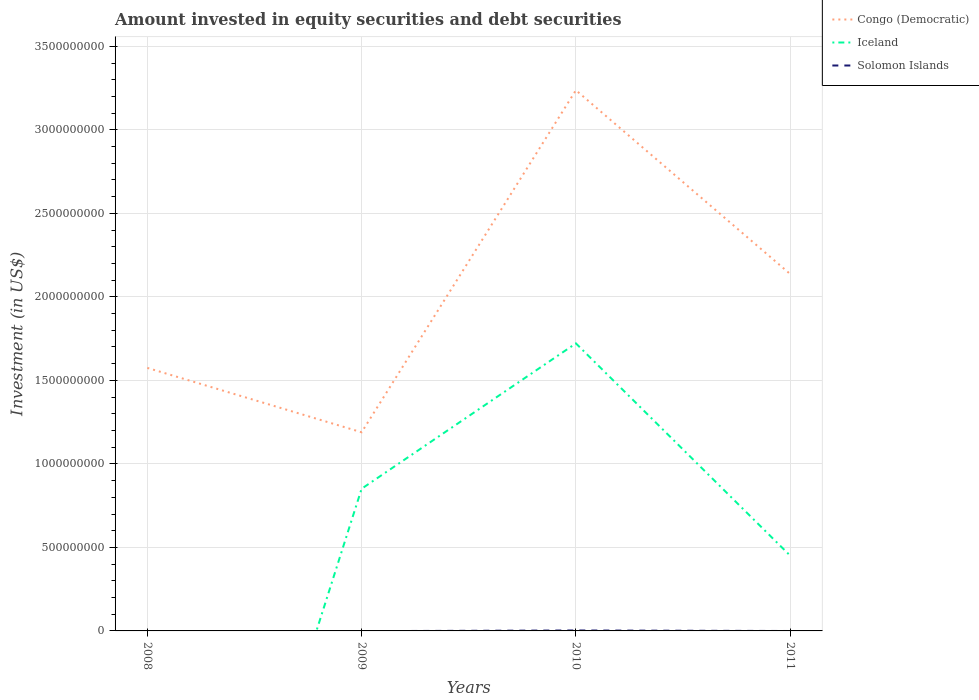Does the line corresponding to Solomon Islands intersect with the line corresponding to Iceland?
Your response must be concise. Yes. Is the number of lines equal to the number of legend labels?
Offer a very short reply. No. Across all years, what is the maximum amount invested in equity securities and debt securities in Iceland?
Provide a short and direct response. 0. What is the total amount invested in equity securities and debt securities in Congo (Democratic) in the graph?
Your response must be concise. -9.48e+08. What is the difference between the highest and the second highest amount invested in equity securities and debt securities in Iceland?
Your answer should be compact. 1.72e+09. Is the amount invested in equity securities and debt securities in Congo (Democratic) strictly greater than the amount invested in equity securities and debt securities in Iceland over the years?
Your answer should be very brief. No. How many lines are there?
Provide a short and direct response. 3. How many years are there in the graph?
Make the answer very short. 4. Where does the legend appear in the graph?
Offer a terse response. Top right. How many legend labels are there?
Your answer should be compact. 3. How are the legend labels stacked?
Your answer should be compact. Vertical. What is the title of the graph?
Provide a short and direct response. Amount invested in equity securities and debt securities. What is the label or title of the Y-axis?
Ensure brevity in your answer.  Investment (in US$). What is the Investment (in US$) in Congo (Democratic) in 2008?
Offer a terse response. 1.57e+09. What is the Investment (in US$) in Iceland in 2008?
Offer a terse response. 0. What is the Investment (in US$) in Solomon Islands in 2008?
Ensure brevity in your answer.  0. What is the Investment (in US$) of Congo (Democratic) in 2009?
Your answer should be compact. 1.19e+09. What is the Investment (in US$) of Iceland in 2009?
Offer a terse response. 8.51e+08. What is the Investment (in US$) in Solomon Islands in 2009?
Make the answer very short. 0. What is the Investment (in US$) in Congo (Democratic) in 2010?
Provide a short and direct response. 3.24e+09. What is the Investment (in US$) of Iceland in 2010?
Offer a terse response. 1.72e+09. What is the Investment (in US$) in Solomon Islands in 2010?
Offer a very short reply. 2.65e+06. What is the Investment (in US$) of Congo (Democratic) in 2011?
Provide a succinct answer. 2.14e+09. What is the Investment (in US$) in Iceland in 2011?
Ensure brevity in your answer.  4.51e+08. What is the Investment (in US$) of Solomon Islands in 2011?
Ensure brevity in your answer.  0. Across all years, what is the maximum Investment (in US$) of Congo (Democratic)?
Provide a short and direct response. 3.24e+09. Across all years, what is the maximum Investment (in US$) of Iceland?
Your answer should be compact. 1.72e+09. Across all years, what is the maximum Investment (in US$) in Solomon Islands?
Offer a very short reply. 2.65e+06. Across all years, what is the minimum Investment (in US$) in Congo (Democratic)?
Your response must be concise. 1.19e+09. What is the total Investment (in US$) of Congo (Democratic) in the graph?
Give a very brief answer. 8.14e+09. What is the total Investment (in US$) of Iceland in the graph?
Your answer should be compact. 3.02e+09. What is the total Investment (in US$) of Solomon Islands in the graph?
Make the answer very short. 2.65e+06. What is the difference between the Investment (in US$) in Congo (Democratic) in 2008 and that in 2009?
Offer a terse response. 3.86e+08. What is the difference between the Investment (in US$) of Congo (Democratic) in 2008 and that in 2010?
Ensure brevity in your answer.  -1.66e+09. What is the difference between the Investment (in US$) in Congo (Democratic) in 2008 and that in 2011?
Ensure brevity in your answer.  -5.62e+08. What is the difference between the Investment (in US$) in Congo (Democratic) in 2009 and that in 2010?
Your response must be concise. -2.05e+09. What is the difference between the Investment (in US$) in Iceland in 2009 and that in 2010?
Make the answer very short. -8.70e+08. What is the difference between the Investment (in US$) of Congo (Democratic) in 2009 and that in 2011?
Your answer should be very brief. -9.48e+08. What is the difference between the Investment (in US$) of Iceland in 2009 and that in 2011?
Provide a short and direct response. 4.01e+08. What is the difference between the Investment (in US$) of Congo (Democratic) in 2010 and that in 2011?
Your answer should be compact. 1.10e+09. What is the difference between the Investment (in US$) of Iceland in 2010 and that in 2011?
Make the answer very short. 1.27e+09. What is the difference between the Investment (in US$) in Congo (Democratic) in 2008 and the Investment (in US$) in Iceland in 2009?
Your response must be concise. 7.24e+08. What is the difference between the Investment (in US$) in Congo (Democratic) in 2008 and the Investment (in US$) in Iceland in 2010?
Offer a terse response. -1.47e+08. What is the difference between the Investment (in US$) in Congo (Democratic) in 2008 and the Investment (in US$) in Solomon Islands in 2010?
Give a very brief answer. 1.57e+09. What is the difference between the Investment (in US$) of Congo (Democratic) in 2008 and the Investment (in US$) of Iceland in 2011?
Keep it short and to the point. 1.12e+09. What is the difference between the Investment (in US$) in Congo (Democratic) in 2009 and the Investment (in US$) in Iceland in 2010?
Your answer should be compact. -5.32e+08. What is the difference between the Investment (in US$) of Congo (Democratic) in 2009 and the Investment (in US$) of Solomon Islands in 2010?
Keep it short and to the point. 1.19e+09. What is the difference between the Investment (in US$) of Iceland in 2009 and the Investment (in US$) of Solomon Islands in 2010?
Ensure brevity in your answer.  8.49e+08. What is the difference between the Investment (in US$) in Congo (Democratic) in 2009 and the Investment (in US$) in Iceland in 2011?
Offer a very short reply. 7.39e+08. What is the difference between the Investment (in US$) of Congo (Democratic) in 2010 and the Investment (in US$) of Iceland in 2011?
Ensure brevity in your answer.  2.79e+09. What is the average Investment (in US$) of Congo (Democratic) per year?
Provide a succinct answer. 2.03e+09. What is the average Investment (in US$) of Iceland per year?
Offer a terse response. 7.56e+08. What is the average Investment (in US$) in Solomon Islands per year?
Ensure brevity in your answer.  6.62e+05. In the year 2009, what is the difference between the Investment (in US$) in Congo (Democratic) and Investment (in US$) in Iceland?
Your answer should be very brief. 3.38e+08. In the year 2010, what is the difference between the Investment (in US$) in Congo (Democratic) and Investment (in US$) in Iceland?
Make the answer very short. 1.52e+09. In the year 2010, what is the difference between the Investment (in US$) in Congo (Democratic) and Investment (in US$) in Solomon Islands?
Provide a succinct answer. 3.23e+09. In the year 2010, what is the difference between the Investment (in US$) in Iceland and Investment (in US$) in Solomon Islands?
Provide a short and direct response. 1.72e+09. In the year 2011, what is the difference between the Investment (in US$) of Congo (Democratic) and Investment (in US$) of Iceland?
Ensure brevity in your answer.  1.69e+09. What is the ratio of the Investment (in US$) of Congo (Democratic) in 2008 to that in 2009?
Give a very brief answer. 1.32. What is the ratio of the Investment (in US$) in Congo (Democratic) in 2008 to that in 2010?
Give a very brief answer. 0.49. What is the ratio of the Investment (in US$) in Congo (Democratic) in 2008 to that in 2011?
Offer a terse response. 0.74. What is the ratio of the Investment (in US$) of Congo (Democratic) in 2009 to that in 2010?
Provide a succinct answer. 0.37. What is the ratio of the Investment (in US$) of Iceland in 2009 to that in 2010?
Offer a very short reply. 0.49. What is the ratio of the Investment (in US$) in Congo (Democratic) in 2009 to that in 2011?
Your answer should be compact. 0.56. What is the ratio of the Investment (in US$) of Iceland in 2009 to that in 2011?
Make the answer very short. 1.89. What is the ratio of the Investment (in US$) in Congo (Democratic) in 2010 to that in 2011?
Offer a very short reply. 1.51. What is the ratio of the Investment (in US$) of Iceland in 2010 to that in 2011?
Keep it short and to the point. 3.82. What is the difference between the highest and the second highest Investment (in US$) of Congo (Democratic)?
Your answer should be compact. 1.10e+09. What is the difference between the highest and the second highest Investment (in US$) in Iceland?
Your response must be concise. 8.70e+08. What is the difference between the highest and the lowest Investment (in US$) of Congo (Democratic)?
Provide a succinct answer. 2.05e+09. What is the difference between the highest and the lowest Investment (in US$) in Iceland?
Give a very brief answer. 1.72e+09. What is the difference between the highest and the lowest Investment (in US$) of Solomon Islands?
Offer a very short reply. 2.65e+06. 